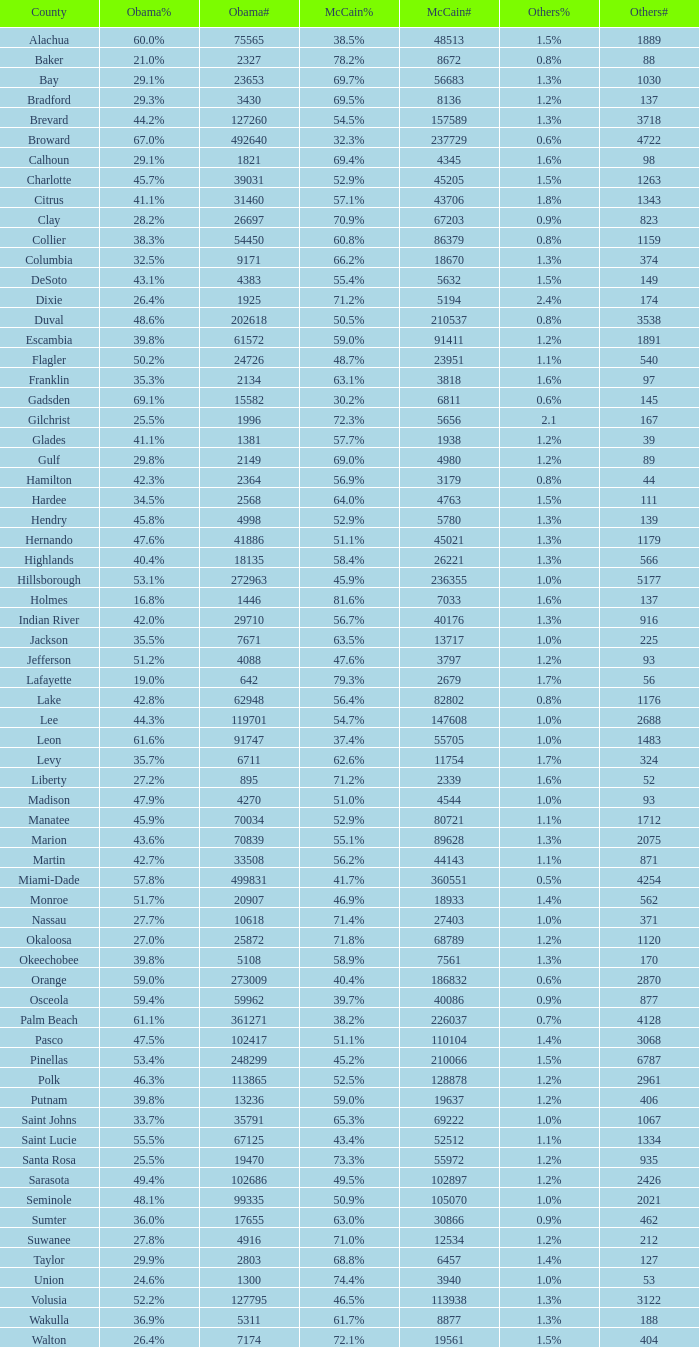Parse the table in full. {'header': ['County', 'Obama%', 'Obama#', 'McCain%', 'McCain#', 'Others%', 'Others#'], 'rows': [['Alachua', '60.0%', '75565', '38.5%', '48513', '1.5%', '1889'], ['Baker', '21.0%', '2327', '78.2%', '8672', '0.8%', '88'], ['Bay', '29.1%', '23653', '69.7%', '56683', '1.3%', '1030'], ['Bradford', '29.3%', '3430', '69.5%', '8136', '1.2%', '137'], ['Brevard', '44.2%', '127260', '54.5%', '157589', '1.3%', '3718'], ['Broward', '67.0%', '492640', '32.3%', '237729', '0.6%', '4722'], ['Calhoun', '29.1%', '1821', '69.4%', '4345', '1.6%', '98'], ['Charlotte', '45.7%', '39031', '52.9%', '45205', '1.5%', '1263'], ['Citrus', '41.1%', '31460', '57.1%', '43706', '1.8%', '1343'], ['Clay', '28.2%', '26697', '70.9%', '67203', '0.9%', '823'], ['Collier', '38.3%', '54450', '60.8%', '86379', '0.8%', '1159'], ['Columbia', '32.5%', '9171', '66.2%', '18670', '1.3%', '374'], ['DeSoto', '43.1%', '4383', '55.4%', '5632', '1.5%', '149'], ['Dixie', '26.4%', '1925', '71.2%', '5194', '2.4%', '174'], ['Duval', '48.6%', '202618', '50.5%', '210537', '0.8%', '3538'], ['Escambia', '39.8%', '61572', '59.0%', '91411', '1.2%', '1891'], ['Flagler', '50.2%', '24726', '48.7%', '23951', '1.1%', '540'], ['Franklin', '35.3%', '2134', '63.1%', '3818', '1.6%', '97'], ['Gadsden', '69.1%', '15582', '30.2%', '6811', '0.6%', '145'], ['Gilchrist', '25.5%', '1996', '72.3%', '5656', '2.1', '167'], ['Glades', '41.1%', '1381', '57.7%', '1938', '1.2%', '39'], ['Gulf', '29.8%', '2149', '69.0%', '4980', '1.2%', '89'], ['Hamilton', '42.3%', '2364', '56.9%', '3179', '0.8%', '44'], ['Hardee', '34.5%', '2568', '64.0%', '4763', '1.5%', '111'], ['Hendry', '45.8%', '4998', '52.9%', '5780', '1.3%', '139'], ['Hernando', '47.6%', '41886', '51.1%', '45021', '1.3%', '1179'], ['Highlands', '40.4%', '18135', '58.4%', '26221', '1.3%', '566'], ['Hillsborough', '53.1%', '272963', '45.9%', '236355', '1.0%', '5177'], ['Holmes', '16.8%', '1446', '81.6%', '7033', '1.6%', '137'], ['Indian River', '42.0%', '29710', '56.7%', '40176', '1.3%', '916'], ['Jackson', '35.5%', '7671', '63.5%', '13717', '1.0%', '225'], ['Jefferson', '51.2%', '4088', '47.6%', '3797', '1.2%', '93'], ['Lafayette', '19.0%', '642', '79.3%', '2679', '1.7%', '56'], ['Lake', '42.8%', '62948', '56.4%', '82802', '0.8%', '1176'], ['Lee', '44.3%', '119701', '54.7%', '147608', '1.0%', '2688'], ['Leon', '61.6%', '91747', '37.4%', '55705', '1.0%', '1483'], ['Levy', '35.7%', '6711', '62.6%', '11754', '1.7%', '324'], ['Liberty', '27.2%', '895', '71.2%', '2339', '1.6%', '52'], ['Madison', '47.9%', '4270', '51.0%', '4544', '1.0%', '93'], ['Manatee', '45.9%', '70034', '52.9%', '80721', '1.1%', '1712'], ['Marion', '43.6%', '70839', '55.1%', '89628', '1.3%', '2075'], ['Martin', '42.7%', '33508', '56.2%', '44143', '1.1%', '871'], ['Miami-Dade', '57.8%', '499831', '41.7%', '360551', '0.5%', '4254'], ['Monroe', '51.7%', '20907', '46.9%', '18933', '1.4%', '562'], ['Nassau', '27.7%', '10618', '71.4%', '27403', '1.0%', '371'], ['Okaloosa', '27.0%', '25872', '71.8%', '68789', '1.2%', '1120'], ['Okeechobee', '39.8%', '5108', '58.9%', '7561', '1.3%', '170'], ['Orange', '59.0%', '273009', '40.4%', '186832', '0.6%', '2870'], ['Osceola', '59.4%', '59962', '39.7%', '40086', '0.9%', '877'], ['Palm Beach', '61.1%', '361271', '38.2%', '226037', '0.7%', '4128'], ['Pasco', '47.5%', '102417', '51.1%', '110104', '1.4%', '3068'], ['Pinellas', '53.4%', '248299', '45.2%', '210066', '1.5%', '6787'], ['Polk', '46.3%', '113865', '52.5%', '128878', '1.2%', '2961'], ['Putnam', '39.8%', '13236', '59.0%', '19637', '1.2%', '406'], ['Saint Johns', '33.7%', '35791', '65.3%', '69222', '1.0%', '1067'], ['Saint Lucie', '55.5%', '67125', '43.4%', '52512', '1.1%', '1334'], ['Santa Rosa', '25.5%', '19470', '73.3%', '55972', '1.2%', '935'], ['Sarasota', '49.4%', '102686', '49.5%', '102897', '1.2%', '2426'], ['Seminole', '48.1%', '99335', '50.9%', '105070', '1.0%', '2021'], ['Sumter', '36.0%', '17655', '63.0%', '30866', '0.9%', '462'], ['Suwanee', '27.8%', '4916', '71.0%', '12534', '1.2%', '212'], ['Taylor', '29.9%', '2803', '68.8%', '6457', '1.4%', '127'], ['Union', '24.6%', '1300', '74.4%', '3940', '1.0%', '53'], ['Volusia', '52.2%', '127795', '46.5%', '113938', '1.3%', '3122'], ['Wakulla', '36.9%', '5311', '61.7%', '8877', '1.3%', '188'], ['Walton', '26.4%', '7174', '72.1%', '19561', '1.5%', '404']]} 0 voters? 1.3%. 